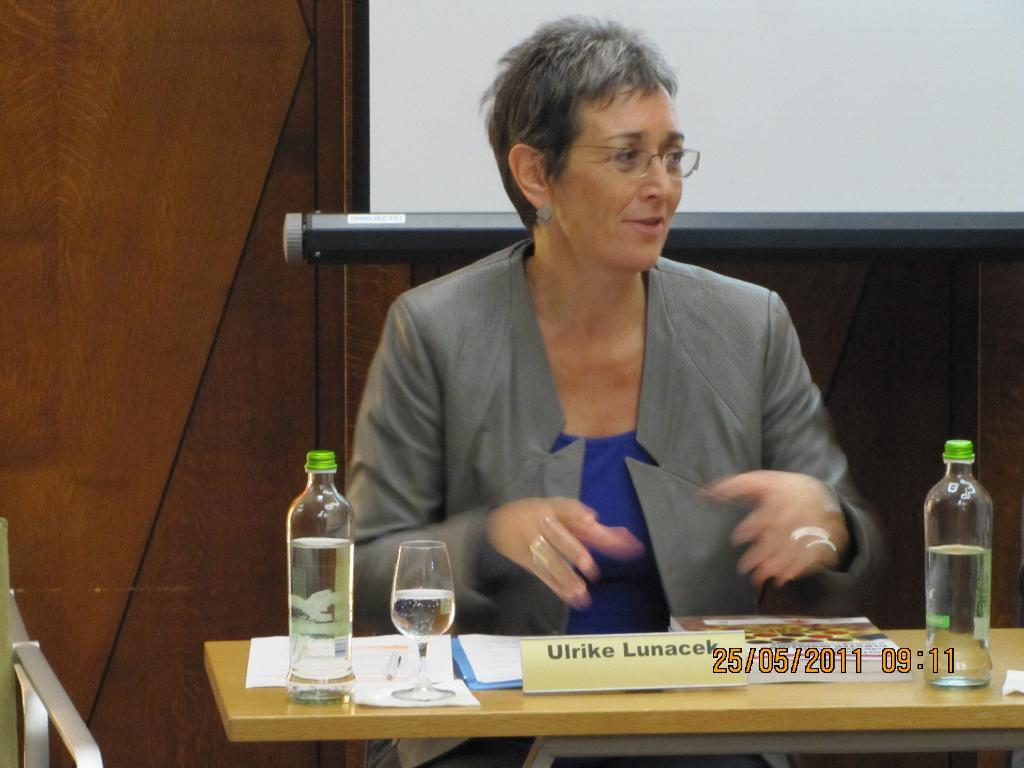<image>
Describe the image concisely. Ulrike Lunacek sits in front of projector screen while looking to her left. 